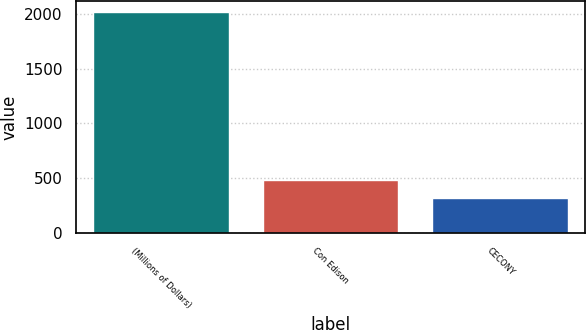Convert chart to OTSL. <chart><loc_0><loc_0><loc_500><loc_500><bar_chart><fcel>(Millions of Dollars)<fcel>Con Edison<fcel>CECONY<nl><fcel>2018<fcel>488<fcel>318<nl></chart> 